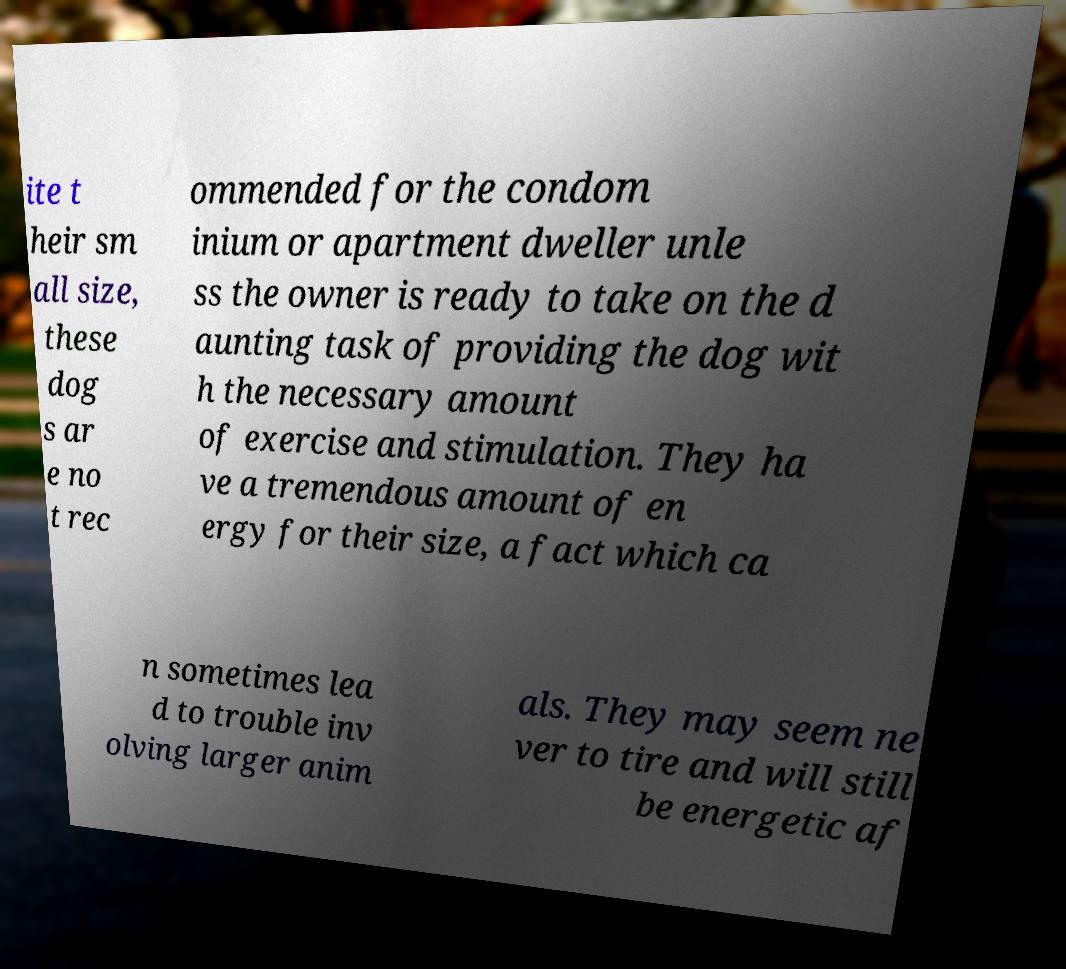Can you accurately transcribe the text from the provided image for me? ite t heir sm all size, these dog s ar e no t rec ommended for the condom inium or apartment dweller unle ss the owner is ready to take on the d aunting task of providing the dog wit h the necessary amount of exercise and stimulation. They ha ve a tremendous amount of en ergy for their size, a fact which ca n sometimes lea d to trouble inv olving larger anim als. They may seem ne ver to tire and will still be energetic af 